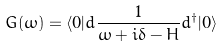<formula> <loc_0><loc_0><loc_500><loc_500>G ( \omega ) = \langle 0 | d \frac { 1 } { \omega + i \delta - H } d ^ { \dagger } | 0 \rangle</formula> 